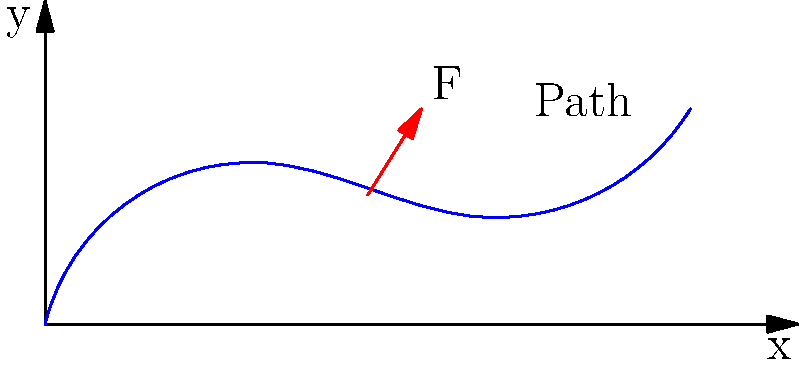Consider a particle moving along the curved path shown in the diagram. A force $\vec{F}$ is applied to the particle at the point $(3, 1.2)$, represented by the red arrow. The force has components $F_x = 50$ N and $F_y = 80$ N. If the particle is displaced by a small amount $ds = 0.1$ m along the path at this point, calculate the work done by the force. Assume the tangent to the path at this point makes an angle of 30° with the positive x-axis. To solve this problem, we'll follow these steps:

1. Recall the formula for work done by a force:
   $$ W = \vec{F} \cdot \vec{ds} = |\vec{F}| |\vec{ds}| \cos\theta $$
   where $\theta$ is the angle between the force and displacement vectors.

2. Calculate the magnitude of the force:
   $$ |\vec{F}| = \sqrt{F_x^2 + F_y^2} = \sqrt{50^2 + 80^2} = \sqrt{9000} = 94.87 \text{ N} $$

3. The displacement vector $\vec{ds}$ is tangent to the path. We're given that it makes a 30° angle with the x-axis. To find the angle between $\vec{F}$ and $\vec{ds}$, we need to calculate the angle of $\vec{F}$ with the x-axis:
   $$ \theta_F = \tan^{-1}(F_y/F_x) = \tan^{-1}(80/50) = 57.99° $$

4. The angle between $\vec{F}$ and $\vec{ds}$ is:
   $$ \theta = 57.99° - 30° = 27.99° $$

5. Now we can calculate the work done:
   $$ W = |\vec{F}| |\vec{ds}| \cos\theta $$
   $$ W = (94.87 \text{ N})(0.1 \text{ m})\cos(27.99°) $$
   $$ W = 9.487 \cos(27.99°) = 8.39 \text{ J} $$

6. Round to two decimal places:
   $$ W = 8.39 \text{ J} $$
Answer: 8.39 J 